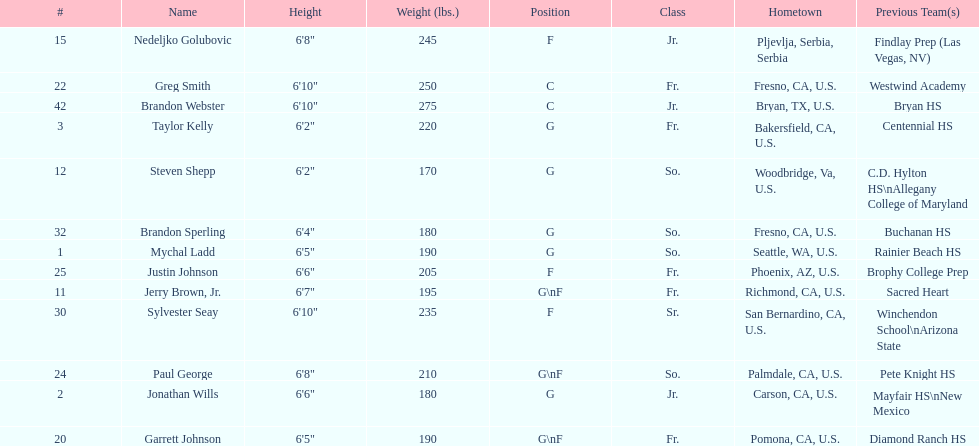Is the number of freshmen (fr.) greater than, equal to, or less than the number of juniors (jr.)? Greater. I'm looking to parse the entire table for insights. Could you assist me with that? {'header': ['#', 'Name', 'Height', 'Weight (lbs.)', 'Position', 'Class', 'Hometown', 'Previous Team(s)'], 'rows': [['15', 'Nedeljko Golubovic', '6\'8"', '245', 'F', 'Jr.', 'Pljevlja, Serbia, Serbia', 'Findlay Prep (Las Vegas, NV)'], ['22', 'Greg Smith', '6\'10"', '250', 'C', 'Fr.', 'Fresno, CA, U.S.', 'Westwind Academy'], ['42', 'Brandon Webster', '6\'10"', '275', 'C', 'Jr.', 'Bryan, TX, U.S.', 'Bryan HS'], ['3', 'Taylor Kelly', '6\'2"', '220', 'G', 'Fr.', 'Bakersfield, CA, U.S.', 'Centennial HS'], ['12', 'Steven Shepp', '6\'2"', '170', 'G', 'So.', 'Woodbridge, Va, U.S.', 'C.D. Hylton HS\\nAllegany College of Maryland'], ['32', 'Brandon Sperling', '6\'4"', '180', 'G', 'So.', 'Fresno, CA, U.S.', 'Buchanan HS'], ['1', 'Mychal Ladd', '6\'5"', '190', 'G', 'So.', 'Seattle, WA, U.S.', 'Rainier Beach HS'], ['25', 'Justin Johnson', '6\'6"', '205', 'F', 'Fr.', 'Phoenix, AZ, U.S.', 'Brophy College Prep'], ['11', 'Jerry Brown, Jr.', '6\'7"', '195', 'G\\nF', 'Fr.', 'Richmond, CA, U.S.', 'Sacred Heart'], ['30', 'Sylvester Seay', '6\'10"', '235', 'F', 'Sr.', 'San Bernardino, CA, U.S.', 'Winchendon School\\nArizona State'], ['24', 'Paul George', '6\'8"', '210', 'G\\nF', 'So.', 'Palmdale, CA, U.S.', 'Pete Knight HS'], ['2', 'Jonathan Wills', '6\'6"', '180', 'G', 'Jr.', 'Carson, CA, U.S.', 'Mayfair HS\\nNew Mexico'], ['20', 'Garrett Johnson', '6\'5"', '190', 'G\\nF', 'Fr.', 'Pomona, CA, U.S.', 'Diamond Ranch HS']]} 